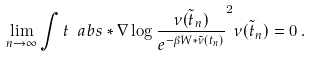Convert formula to latex. <formula><loc_0><loc_0><loc_500><loc_500>\lim _ { n \to \infty } \int t { \ a b s * { \nabla \log \frac { \tilde { \nu ( t _ { n } ) } } { e ^ { - \beta W \ast \tilde { \nu } ( t _ { n } ) } } } ^ { 2 } \tilde { \nu ( t _ { n } ) } } = 0 \, .</formula> 